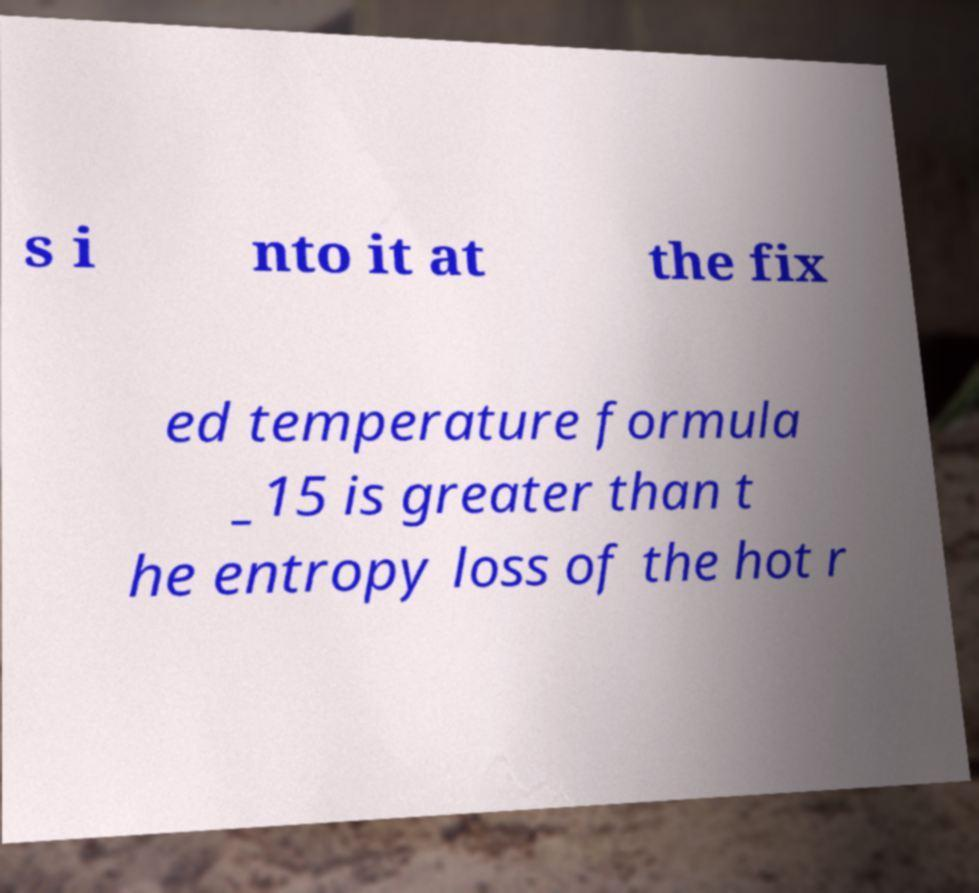Could you assist in decoding the text presented in this image and type it out clearly? s i nto it at the fix ed temperature formula _15 is greater than t he entropy loss of the hot r 